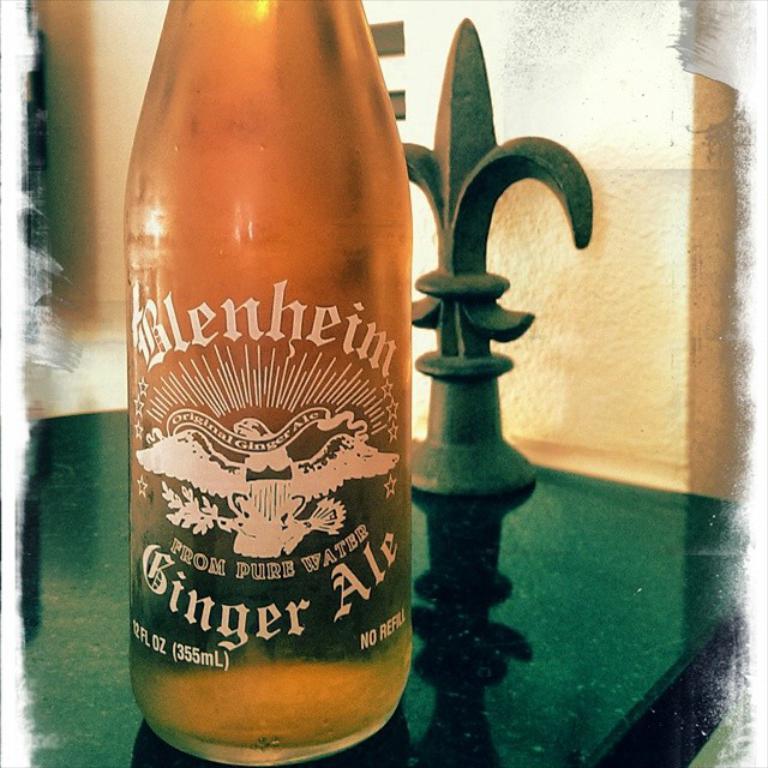How many ml is this bottle?
Ensure brevity in your answer.  355. 